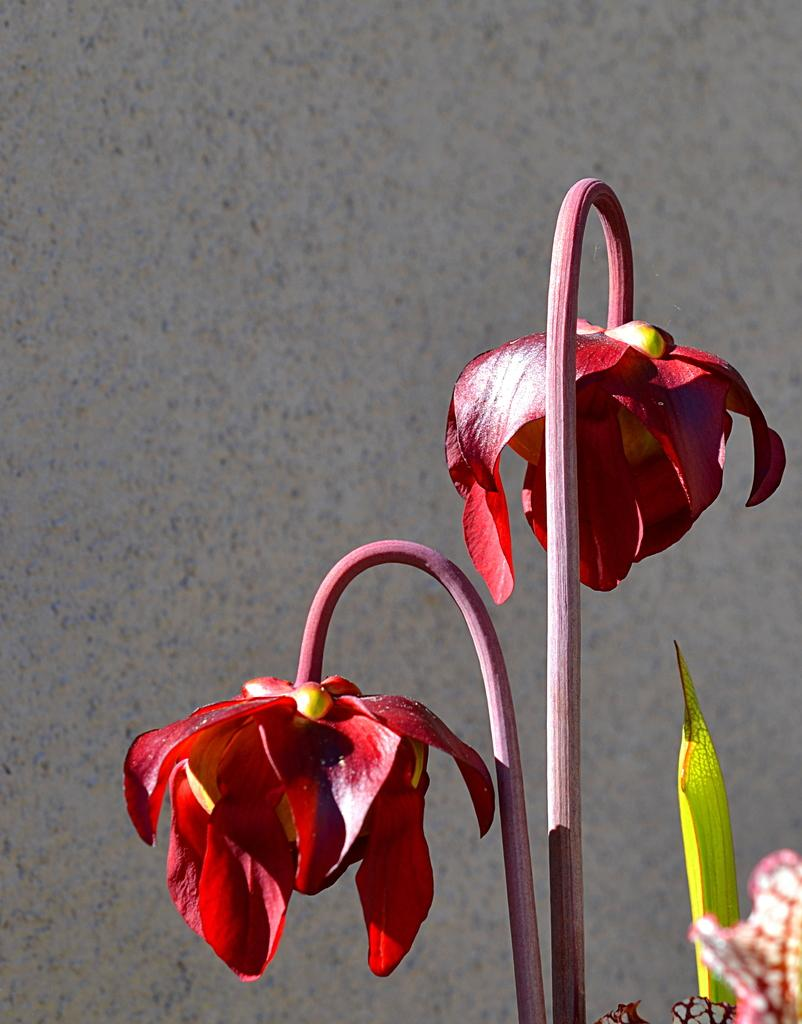What type of plants are in the image? There are stems with flowers in the image. What can be seen in the background of the image? There is a wall visible in the background of the image. What type of bit is used by the church in the image? There is no church or bit present in the image; it features stems with flowers and a wall in the background. 